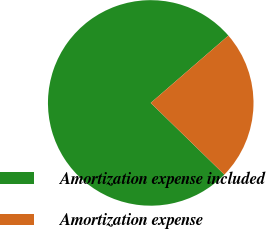<chart> <loc_0><loc_0><loc_500><loc_500><pie_chart><fcel>Amortization expense included<fcel>Amortization expense<nl><fcel>76.35%<fcel>23.65%<nl></chart> 